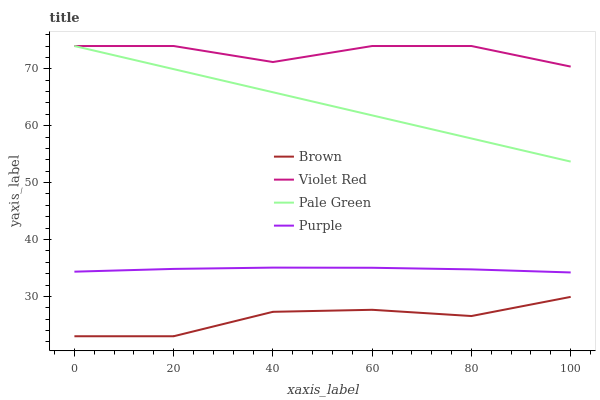Does Brown have the minimum area under the curve?
Answer yes or no. Yes. Does Violet Red have the maximum area under the curve?
Answer yes or no. Yes. Does Violet Red have the minimum area under the curve?
Answer yes or no. No. Does Brown have the maximum area under the curve?
Answer yes or no. No. Is Pale Green the smoothest?
Answer yes or no. Yes. Is Violet Red the roughest?
Answer yes or no. Yes. Is Brown the smoothest?
Answer yes or no. No. Is Brown the roughest?
Answer yes or no. No. Does Brown have the lowest value?
Answer yes or no. Yes. Does Violet Red have the lowest value?
Answer yes or no. No. Does Pale Green have the highest value?
Answer yes or no. Yes. Does Brown have the highest value?
Answer yes or no. No. Is Purple less than Violet Red?
Answer yes or no. Yes. Is Pale Green greater than Brown?
Answer yes or no. Yes. Does Pale Green intersect Violet Red?
Answer yes or no. Yes. Is Pale Green less than Violet Red?
Answer yes or no. No. Is Pale Green greater than Violet Red?
Answer yes or no. No. Does Purple intersect Violet Red?
Answer yes or no. No. 